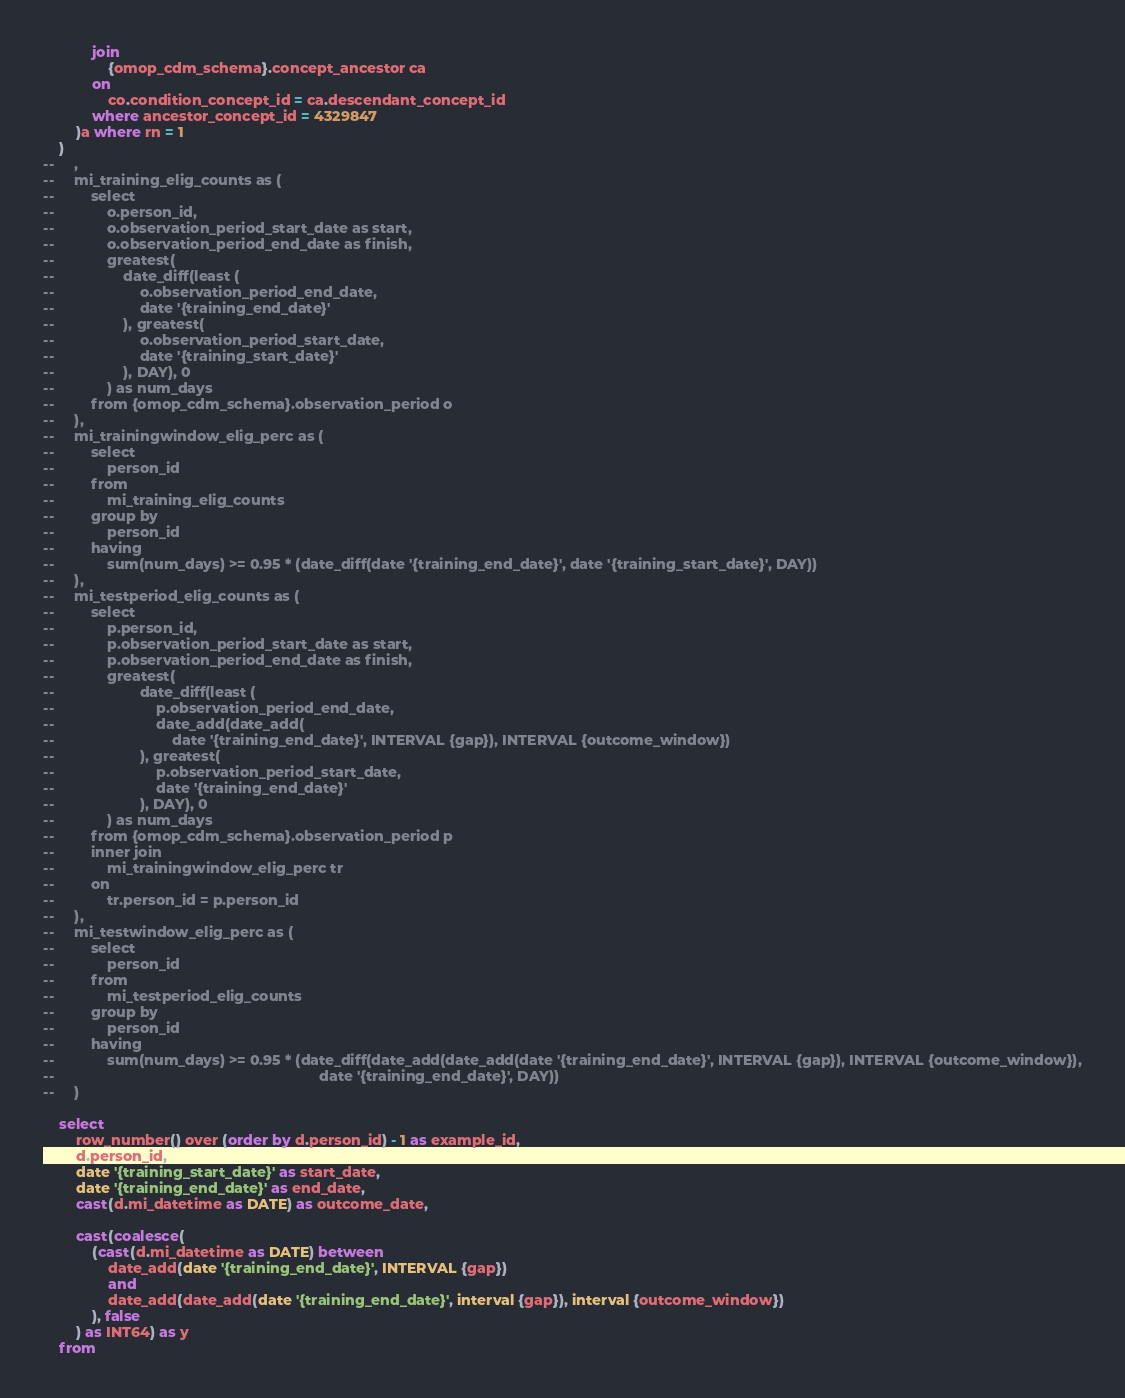Convert code to text. <code><loc_0><loc_0><loc_500><loc_500><_SQL_>            join 
                {omop_cdm_schema}.concept_ancestor ca
            on 
                co.condition_concept_id = ca.descendant_concept_id
            where ancestor_concept_id = 4329847
        )a where rn = 1
    )
--     ,
--     mi_training_elig_counts as (
--         select
--             o.person_id,
--             o.observation_period_start_date as start,
--             o.observation_period_end_date as finish,
--             greatest(
--                 date_diff(least (
--                     o.observation_period_end_date,
--                     date '{training_end_date}'
--                 ), greatest(
--                     o.observation_period_start_date,
--                     date '{training_start_date}'
--                 ), DAY), 0
--             ) as num_days
--         from {omop_cdm_schema}.observation_period o
--     ),
--     mi_trainingwindow_elig_perc as (
--         select
--             person_id
--         from
--             mi_training_elig_counts
--         group by
--             person_id
--         having
--             sum(num_days) >= 0.95 * (date_diff(date '{training_end_date}', date '{training_start_date}', DAY))
--     ),
--     mi_testperiod_elig_counts as (
--         select
--             p.person_id,
--             p.observation_period_start_date as start,
--             p.observation_period_end_date as finish,
--             greatest(
--                     date_diff(least (
--                         p.observation_period_end_date,
--                         date_add(date_add(
--                             date '{training_end_date}', INTERVAL {gap}), INTERVAL {outcome_window})
--                     ), greatest(
--                         p.observation_period_start_date,
--                         date '{training_end_date}'
--                     ), DAY), 0
--             ) as num_days
--         from {omop_cdm_schema}.observation_period p
--         inner join 
--             mi_trainingwindow_elig_perc tr
--         on 
--             tr.person_id = p.person_id
--     ), 
--     mi_testwindow_elig_perc as (
--         select
--             person_id
--         from
--             mi_testperiod_elig_counts
--         group by 
--             person_id
--         having
--             sum(num_days) >= 0.95 * (date_diff(date_add(date_add(date '{training_end_date}', INTERVAL {gap}), INTERVAL {outcome_window}),
--                                                                 date '{training_end_date}', DAY))
--     ) 
    
    select
        row_number() over (order by d.person_id) - 1 as example_id,
        d.person_id,
        date '{training_start_date}' as start_date,
        date '{training_end_date}' as end_date,
        cast(d.mi_datetime as DATE) as outcome_date,
        
        cast(coalesce(
            (cast(d.mi_datetime as DATE) between
                date_add(date '{training_end_date}', INTERVAL {gap})
                and
                date_add(date_add(date '{training_end_date}', interval {gap}), interval {outcome_window})
            ), false
        ) as INT64) as y
    from</code> 